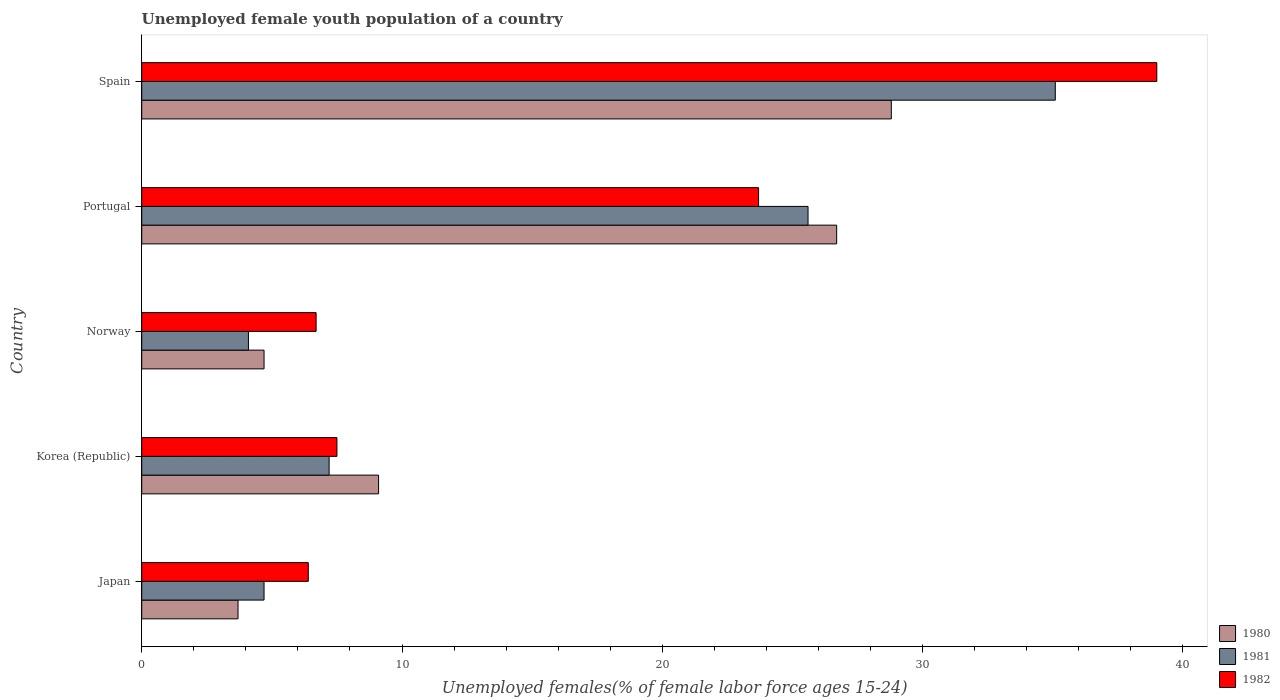How many groups of bars are there?
Your answer should be compact. 5. How many bars are there on the 1st tick from the bottom?
Provide a short and direct response. 3. In how many cases, is the number of bars for a given country not equal to the number of legend labels?
Keep it short and to the point. 0. Across all countries, what is the maximum percentage of unemployed female youth population in 1982?
Your answer should be very brief. 39. Across all countries, what is the minimum percentage of unemployed female youth population in 1981?
Make the answer very short. 4.1. In which country was the percentage of unemployed female youth population in 1980 minimum?
Your answer should be compact. Japan. What is the total percentage of unemployed female youth population in 1980 in the graph?
Provide a succinct answer. 73. What is the difference between the percentage of unemployed female youth population in 1981 in Korea (Republic) and that in Portugal?
Provide a succinct answer. -18.4. What is the average percentage of unemployed female youth population in 1982 per country?
Keep it short and to the point. 16.66. What is the difference between the percentage of unemployed female youth population in 1981 and percentage of unemployed female youth population in 1982 in Japan?
Your response must be concise. -1.7. In how many countries, is the percentage of unemployed female youth population in 1982 greater than 18 %?
Offer a very short reply. 2. What is the ratio of the percentage of unemployed female youth population in 1982 in Japan to that in Norway?
Make the answer very short. 0.96. Is the difference between the percentage of unemployed female youth population in 1981 in Norway and Portugal greater than the difference between the percentage of unemployed female youth population in 1982 in Norway and Portugal?
Make the answer very short. No. What is the difference between the highest and the second highest percentage of unemployed female youth population in 1980?
Provide a short and direct response. 2.1. What is the difference between the highest and the lowest percentage of unemployed female youth population in 1982?
Make the answer very short. 32.6. Is the sum of the percentage of unemployed female youth population in 1981 in Korea (Republic) and Spain greater than the maximum percentage of unemployed female youth population in 1980 across all countries?
Offer a terse response. Yes. What does the 2nd bar from the top in Spain represents?
Provide a short and direct response. 1981. What does the 2nd bar from the bottom in Spain represents?
Your answer should be very brief. 1981. Is it the case that in every country, the sum of the percentage of unemployed female youth population in 1981 and percentage of unemployed female youth population in 1980 is greater than the percentage of unemployed female youth population in 1982?
Offer a terse response. Yes. Are all the bars in the graph horizontal?
Give a very brief answer. Yes. What is the difference between two consecutive major ticks on the X-axis?
Your answer should be very brief. 10. Does the graph contain any zero values?
Give a very brief answer. No. How many legend labels are there?
Your response must be concise. 3. What is the title of the graph?
Your response must be concise. Unemployed female youth population of a country. What is the label or title of the X-axis?
Your answer should be compact. Unemployed females(% of female labor force ages 15-24). What is the label or title of the Y-axis?
Your answer should be compact. Country. What is the Unemployed females(% of female labor force ages 15-24) in 1980 in Japan?
Provide a succinct answer. 3.7. What is the Unemployed females(% of female labor force ages 15-24) of 1981 in Japan?
Give a very brief answer. 4.7. What is the Unemployed females(% of female labor force ages 15-24) of 1982 in Japan?
Provide a succinct answer. 6.4. What is the Unemployed females(% of female labor force ages 15-24) of 1980 in Korea (Republic)?
Offer a very short reply. 9.1. What is the Unemployed females(% of female labor force ages 15-24) of 1981 in Korea (Republic)?
Make the answer very short. 7.2. What is the Unemployed females(% of female labor force ages 15-24) of 1982 in Korea (Republic)?
Ensure brevity in your answer.  7.5. What is the Unemployed females(% of female labor force ages 15-24) in 1980 in Norway?
Make the answer very short. 4.7. What is the Unemployed females(% of female labor force ages 15-24) of 1981 in Norway?
Ensure brevity in your answer.  4.1. What is the Unemployed females(% of female labor force ages 15-24) of 1982 in Norway?
Make the answer very short. 6.7. What is the Unemployed females(% of female labor force ages 15-24) of 1980 in Portugal?
Offer a very short reply. 26.7. What is the Unemployed females(% of female labor force ages 15-24) in 1981 in Portugal?
Your answer should be compact. 25.6. What is the Unemployed females(% of female labor force ages 15-24) of 1982 in Portugal?
Ensure brevity in your answer.  23.7. What is the Unemployed females(% of female labor force ages 15-24) of 1980 in Spain?
Keep it short and to the point. 28.8. What is the Unemployed females(% of female labor force ages 15-24) in 1981 in Spain?
Make the answer very short. 35.1. Across all countries, what is the maximum Unemployed females(% of female labor force ages 15-24) in 1980?
Your answer should be compact. 28.8. Across all countries, what is the maximum Unemployed females(% of female labor force ages 15-24) in 1981?
Provide a short and direct response. 35.1. Across all countries, what is the maximum Unemployed females(% of female labor force ages 15-24) in 1982?
Provide a succinct answer. 39. Across all countries, what is the minimum Unemployed females(% of female labor force ages 15-24) in 1980?
Ensure brevity in your answer.  3.7. Across all countries, what is the minimum Unemployed females(% of female labor force ages 15-24) in 1981?
Ensure brevity in your answer.  4.1. Across all countries, what is the minimum Unemployed females(% of female labor force ages 15-24) in 1982?
Your answer should be compact. 6.4. What is the total Unemployed females(% of female labor force ages 15-24) in 1981 in the graph?
Your answer should be very brief. 76.7. What is the total Unemployed females(% of female labor force ages 15-24) in 1982 in the graph?
Your response must be concise. 83.3. What is the difference between the Unemployed females(% of female labor force ages 15-24) in 1981 in Japan and that in Korea (Republic)?
Make the answer very short. -2.5. What is the difference between the Unemployed females(% of female labor force ages 15-24) in 1982 in Japan and that in Korea (Republic)?
Give a very brief answer. -1.1. What is the difference between the Unemployed females(% of female labor force ages 15-24) in 1981 in Japan and that in Portugal?
Ensure brevity in your answer.  -20.9. What is the difference between the Unemployed females(% of female labor force ages 15-24) in 1982 in Japan and that in Portugal?
Your answer should be compact. -17.3. What is the difference between the Unemployed females(% of female labor force ages 15-24) of 1980 in Japan and that in Spain?
Ensure brevity in your answer.  -25.1. What is the difference between the Unemployed females(% of female labor force ages 15-24) in 1981 in Japan and that in Spain?
Your answer should be compact. -30.4. What is the difference between the Unemployed females(% of female labor force ages 15-24) in 1982 in Japan and that in Spain?
Provide a succinct answer. -32.6. What is the difference between the Unemployed females(% of female labor force ages 15-24) in 1982 in Korea (Republic) and that in Norway?
Ensure brevity in your answer.  0.8. What is the difference between the Unemployed females(% of female labor force ages 15-24) of 1980 in Korea (Republic) and that in Portugal?
Provide a short and direct response. -17.6. What is the difference between the Unemployed females(% of female labor force ages 15-24) of 1981 in Korea (Republic) and that in Portugal?
Give a very brief answer. -18.4. What is the difference between the Unemployed females(% of female labor force ages 15-24) of 1982 in Korea (Republic) and that in Portugal?
Make the answer very short. -16.2. What is the difference between the Unemployed females(% of female labor force ages 15-24) of 1980 in Korea (Republic) and that in Spain?
Ensure brevity in your answer.  -19.7. What is the difference between the Unemployed females(% of female labor force ages 15-24) of 1981 in Korea (Republic) and that in Spain?
Your response must be concise. -27.9. What is the difference between the Unemployed females(% of female labor force ages 15-24) in 1982 in Korea (Republic) and that in Spain?
Keep it short and to the point. -31.5. What is the difference between the Unemployed females(% of female labor force ages 15-24) of 1980 in Norway and that in Portugal?
Offer a terse response. -22. What is the difference between the Unemployed females(% of female labor force ages 15-24) in 1981 in Norway and that in Portugal?
Ensure brevity in your answer.  -21.5. What is the difference between the Unemployed females(% of female labor force ages 15-24) in 1980 in Norway and that in Spain?
Offer a very short reply. -24.1. What is the difference between the Unemployed females(% of female labor force ages 15-24) in 1981 in Norway and that in Spain?
Offer a very short reply. -31. What is the difference between the Unemployed females(% of female labor force ages 15-24) of 1982 in Norway and that in Spain?
Your answer should be compact. -32.3. What is the difference between the Unemployed females(% of female labor force ages 15-24) in 1980 in Portugal and that in Spain?
Keep it short and to the point. -2.1. What is the difference between the Unemployed females(% of female labor force ages 15-24) in 1982 in Portugal and that in Spain?
Keep it short and to the point. -15.3. What is the difference between the Unemployed females(% of female labor force ages 15-24) of 1980 in Japan and the Unemployed females(% of female labor force ages 15-24) of 1981 in Korea (Republic)?
Offer a terse response. -3.5. What is the difference between the Unemployed females(% of female labor force ages 15-24) in 1980 in Japan and the Unemployed females(% of female labor force ages 15-24) in 1982 in Korea (Republic)?
Provide a short and direct response. -3.8. What is the difference between the Unemployed females(% of female labor force ages 15-24) in 1980 in Japan and the Unemployed females(% of female labor force ages 15-24) in 1981 in Norway?
Keep it short and to the point. -0.4. What is the difference between the Unemployed females(% of female labor force ages 15-24) of 1980 in Japan and the Unemployed females(% of female labor force ages 15-24) of 1982 in Norway?
Provide a succinct answer. -3. What is the difference between the Unemployed females(% of female labor force ages 15-24) in 1981 in Japan and the Unemployed females(% of female labor force ages 15-24) in 1982 in Norway?
Your answer should be very brief. -2. What is the difference between the Unemployed females(% of female labor force ages 15-24) in 1980 in Japan and the Unemployed females(% of female labor force ages 15-24) in 1981 in Portugal?
Offer a terse response. -21.9. What is the difference between the Unemployed females(% of female labor force ages 15-24) of 1980 in Japan and the Unemployed females(% of female labor force ages 15-24) of 1982 in Portugal?
Your answer should be compact. -20. What is the difference between the Unemployed females(% of female labor force ages 15-24) of 1980 in Japan and the Unemployed females(% of female labor force ages 15-24) of 1981 in Spain?
Make the answer very short. -31.4. What is the difference between the Unemployed females(% of female labor force ages 15-24) of 1980 in Japan and the Unemployed females(% of female labor force ages 15-24) of 1982 in Spain?
Offer a very short reply. -35.3. What is the difference between the Unemployed females(% of female labor force ages 15-24) in 1981 in Japan and the Unemployed females(% of female labor force ages 15-24) in 1982 in Spain?
Provide a succinct answer. -34.3. What is the difference between the Unemployed females(% of female labor force ages 15-24) in 1981 in Korea (Republic) and the Unemployed females(% of female labor force ages 15-24) in 1982 in Norway?
Keep it short and to the point. 0.5. What is the difference between the Unemployed females(% of female labor force ages 15-24) in 1980 in Korea (Republic) and the Unemployed females(% of female labor force ages 15-24) in 1981 in Portugal?
Keep it short and to the point. -16.5. What is the difference between the Unemployed females(% of female labor force ages 15-24) of 1980 in Korea (Republic) and the Unemployed females(% of female labor force ages 15-24) of 1982 in Portugal?
Provide a succinct answer. -14.6. What is the difference between the Unemployed females(% of female labor force ages 15-24) of 1981 in Korea (Republic) and the Unemployed females(% of female labor force ages 15-24) of 1982 in Portugal?
Your response must be concise. -16.5. What is the difference between the Unemployed females(% of female labor force ages 15-24) in 1980 in Korea (Republic) and the Unemployed females(% of female labor force ages 15-24) in 1981 in Spain?
Your response must be concise. -26. What is the difference between the Unemployed females(% of female labor force ages 15-24) of 1980 in Korea (Republic) and the Unemployed females(% of female labor force ages 15-24) of 1982 in Spain?
Your answer should be very brief. -29.9. What is the difference between the Unemployed females(% of female labor force ages 15-24) in 1981 in Korea (Republic) and the Unemployed females(% of female labor force ages 15-24) in 1982 in Spain?
Make the answer very short. -31.8. What is the difference between the Unemployed females(% of female labor force ages 15-24) in 1980 in Norway and the Unemployed females(% of female labor force ages 15-24) in 1981 in Portugal?
Your answer should be very brief. -20.9. What is the difference between the Unemployed females(% of female labor force ages 15-24) of 1980 in Norway and the Unemployed females(% of female labor force ages 15-24) of 1982 in Portugal?
Ensure brevity in your answer.  -19. What is the difference between the Unemployed females(% of female labor force ages 15-24) in 1981 in Norway and the Unemployed females(% of female labor force ages 15-24) in 1982 in Portugal?
Provide a short and direct response. -19.6. What is the difference between the Unemployed females(% of female labor force ages 15-24) of 1980 in Norway and the Unemployed females(% of female labor force ages 15-24) of 1981 in Spain?
Your response must be concise. -30.4. What is the difference between the Unemployed females(% of female labor force ages 15-24) in 1980 in Norway and the Unemployed females(% of female labor force ages 15-24) in 1982 in Spain?
Offer a terse response. -34.3. What is the difference between the Unemployed females(% of female labor force ages 15-24) in 1981 in Norway and the Unemployed females(% of female labor force ages 15-24) in 1982 in Spain?
Ensure brevity in your answer.  -34.9. What is the difference between the Unemployed females(% of female labor force ages 15-24) of 1980 in Portugal and the Unemployed females(% of female labor force ages 15-24) of 1981 in Spain?
Your answer should be compact. -8.4. What is the difference between the Unemployed females(% of female labor force ages 15-24) in 1980 in Portugal and the Unemployed females(% of female labor force ages 15-24) in 1982 in Spain?
Give a very brief answer. -12.3. What is the average Unemployed females(% of female labor force ages 15-24) of 1980 per country?
Your answer should be compact. 14.6. What is the average Unemployed females(% of female labor force ages 15-24) of 1981 per country?
Your response must be concise. 15.34. What is the average Unemployed females(% of female labor force ages 15-24) in 1982 per country?
Give a very brief answer. 16.66. What is the difference between the Unemployed females(% of female labor force ages 15-24) in 1980 and Unemployed females(% of female labor force ages 15-24) in 1982 in Japan?
Ensure brevity in your answer.  -2.7. What is the difference between the Unemployed females(% of female labor force ages 15-24) of 1981 and Unemployed females(% of female labor force ages 15-24) of 1982 in Japan?
Your answer should be compact. -1.7. What is the difference between the Unemployed females(% of female labor force ages 15-24) of 1981 and Unemployed females(% of female labor force ages 15-24) of 1982 in Korea (Republic)?
Your response must be concise. -0.3. What is the difference between the Unemployed females(% of female labor force ages 15-24) in 1980 and Unemployed females(% of female labor force ages 15-24) in 1981 in Norway?
Your answer should be very brief. 0.6. What is the difference between the Unemployed females(% of female labor force ages 15-24) of 1980 and Unemployed females(% of female labor force ages 15-24) of 1982 in Norway?
Your answer should be very brief. -2. What is the difference between the Unemployed females(% of female labor force ages 15-24) in 1980 and Unemployed females(% of female labor force ages 15-24) in 1981 in Portugal?
Your response must be concise. 1.1. What is the difference between the Unemployed females(% of female labor force ages 15-24) in 1981 and Unemployed females(% of female labor force ages 15-24) in 1982 in Portugal?
Give a very brief answer. 1.9. What is the difference between the Unemployed females(% of female labor force ages 15-24) of 1981 and Unemployed females(% of female labor force ages 15-24) of 1982 in Spain?
Make the answer very short. -3.9. What is the ratio of the Unemployed females(% of female labor force ages 15-24) in 1980 in Japan to that in Korea (Republic)?
Offer a very short reply. 0.41. What is the ratio of the Unemployed females(% of female labor force ages 15-24) of 1981 in Japan to that in Korea (Republic)?
Offer a very short reply. 0.65. What is the ratio of the Unemployed females(% of female labor force ages 15-24) of 1982 in Japan to that in Korea (Republic)?
Your answer should be compact. 0.85. What is the ratio of the Unemployed females(% of female labor force ages 15-24) of 1980 in Japan to that in Norway?
Give a very brief answer. 0.79. What is the ratio of the Unemployed females(% of female labor force ages 15-24) of 1981 in Japan to that in Norway?
Provide a short and direct response. 1.15. What is the ratio of the Unemployed females(% of female labor force ages 15-24) of 1982 in Japan to that in Norway?
Your answer should be compact. 0.96. What is the ratio of the Unemployed females(% of female labor force ages 15-24) in 1980 in Japan to that in Portugal?
Your answer should be very brief. 0.14. What is the ratio of the Unemployed females(% of female labor force ages 15-24) of 1981 in Japan to that in Portugal?
Give a very brief answer. 0.18. What is the ratio of the Unemployed females(% of female labor force ages 15-24) of 1982 in Japan to that in Portugal?
Offer a very short reply. 0.27. What is the ratio of the Unemployed females(% of female labor force ages 15-24) of 1980 in Japan to that in Spain?
Offer a terse response. 0.13. What is the ratio of the Unemployed females(% of female labor force ages 15-24) of 1981 in Japan to that in Spain?
Your response must be concise. 0.13. What is the ratio of the Unemployed females(% of female labor force ages 15-24) of 1982 in Japan to that in Spain?
Keep it short and to the point. 0.16. What is the ratio of the Unemployed females(% of female labor force ages 15-24) of 1980 in Korea (Republic) to that in Norway?
Your answer should be very brief. 1.94. What is the ratio of the Unemployed females(% of female labor force ages 15-24) in 1981 in Korea (Republic) to that in Norway?
Your response must be concise. 1.76. What is the ratio of the Unemployed females(% of female labor force ages 15-24) of 1982 in Korea (Republic) to that in Norway?
Keep it short and to the point. 1.12. What is the ratio of the Unemployed females(% of female labor force ages 15-24) in 1980 in Korea (Republic) to that in Portugal?
Provide a succinct answer. 0.34. What is the ratio of the Unemployed females(% of female labor force ages 15-24) in 1981 in Korea (Republic) to that in Portugal?
Offer a terse response. 0.28. What is the ratio of the Unemployed females(% of female labor force ages 15-24) of 1982 in Korea (Republic) to that in Portugal?
Your response must be concise. 0.32. What is the ratio of the Unemployed females(% of female labor force ages 15-24) in 1980 in Korea (Republic) to that in Spain?
Provide a succinct answer. 0.32. What is the ratio of the Unemployed females(% of female labor force ages 15-24) in 1981 in Korea (Republic) to that in Spain?
Keep it short and to the point. 0.21. What is the ratio of the Unemployed females(% of female labor force ages 15-24) of 1982 in Korea (Republic) to that in Spain?
Provide a succinct answer. 0.19. What is the ratio of the Unemployed females(% of female labor force ages 15-24) of 1980 in Norway to that in Portugal?
Offer a very short reply. 0.18. What is the ratio of the Unemployed females(% of female labor force ages 15-24) of 1981 in Norway to that in Portugal?
Your response must be concise. 0.16. What is the ratio of the Unemployed females(% of female labor force ages 15-24) in 1982 in Norway to that in Portugal?
Your response must be concise. 0.28. What is the ratio of the Unemployed females(% of female labor force ages 15-24) of 1980 in Norway to that in Spain?
Ensure brevity in your answer.  0.16. What is the ratio of the Unemployed females(% of female labor force ages 15-24) of 1981 in Norway to that in Spain?
Your response must be concise. 0.12. What is the ratio of the Unemployed females(% of female labor force ages 15-24) of 1982 in Norway to that in Spain?
Provide a short and direct response. 0.17. What is the ratio of the Unemployed females(% of female labor force ages 15-24) of 1980 in Portugal to that in Spain?
Give a very brief answer. 0.93. What is the ratio of the Unemployed females(% of female labor force ages 15-24) in 1981 in Portugal to that in Spain?
Provide a short and direct response. 0.73. What is the ratio of the Unemployed females(% of female labor force ages 15-24) in 1982 in Portugal to that in Spain?
Ensure brevity in your answer.  0.61. What is the difference between the highest and the second highest Unemployed females(% of female labor force ages 15-24) in 1980?
Your answer should be very brief. 2.1. What is the difference between the highest and the lowest Unemployed females(% of female labor force ages 15-24) in 1980?
Offer a very short reply. 25.1. What is the difference between the highest and the lowest Unemployed females(% of female labor force ages 15-24) in 1981?
Keep it short and to the point. 31. What is the difference between the highest and the lowest Unemployed females(% of female labor force ages 15-24) in 1982?
Offer a terse response. 32.6. 